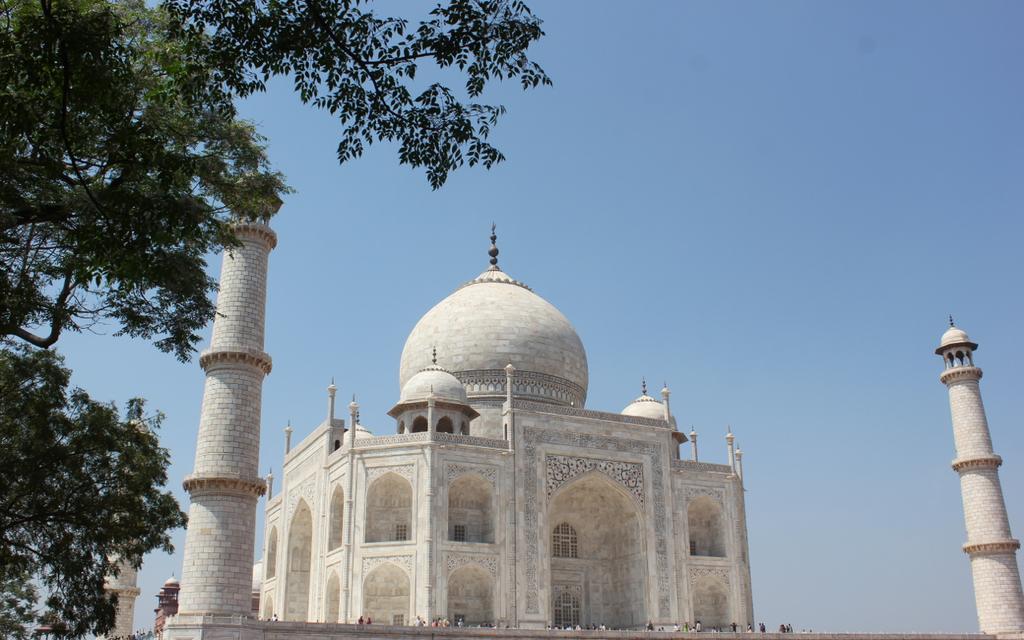How would you summarize this image in a sentence or two? In this picture we can see a Taj Mahal, trees and a group of people and in the background we can see the sky. 